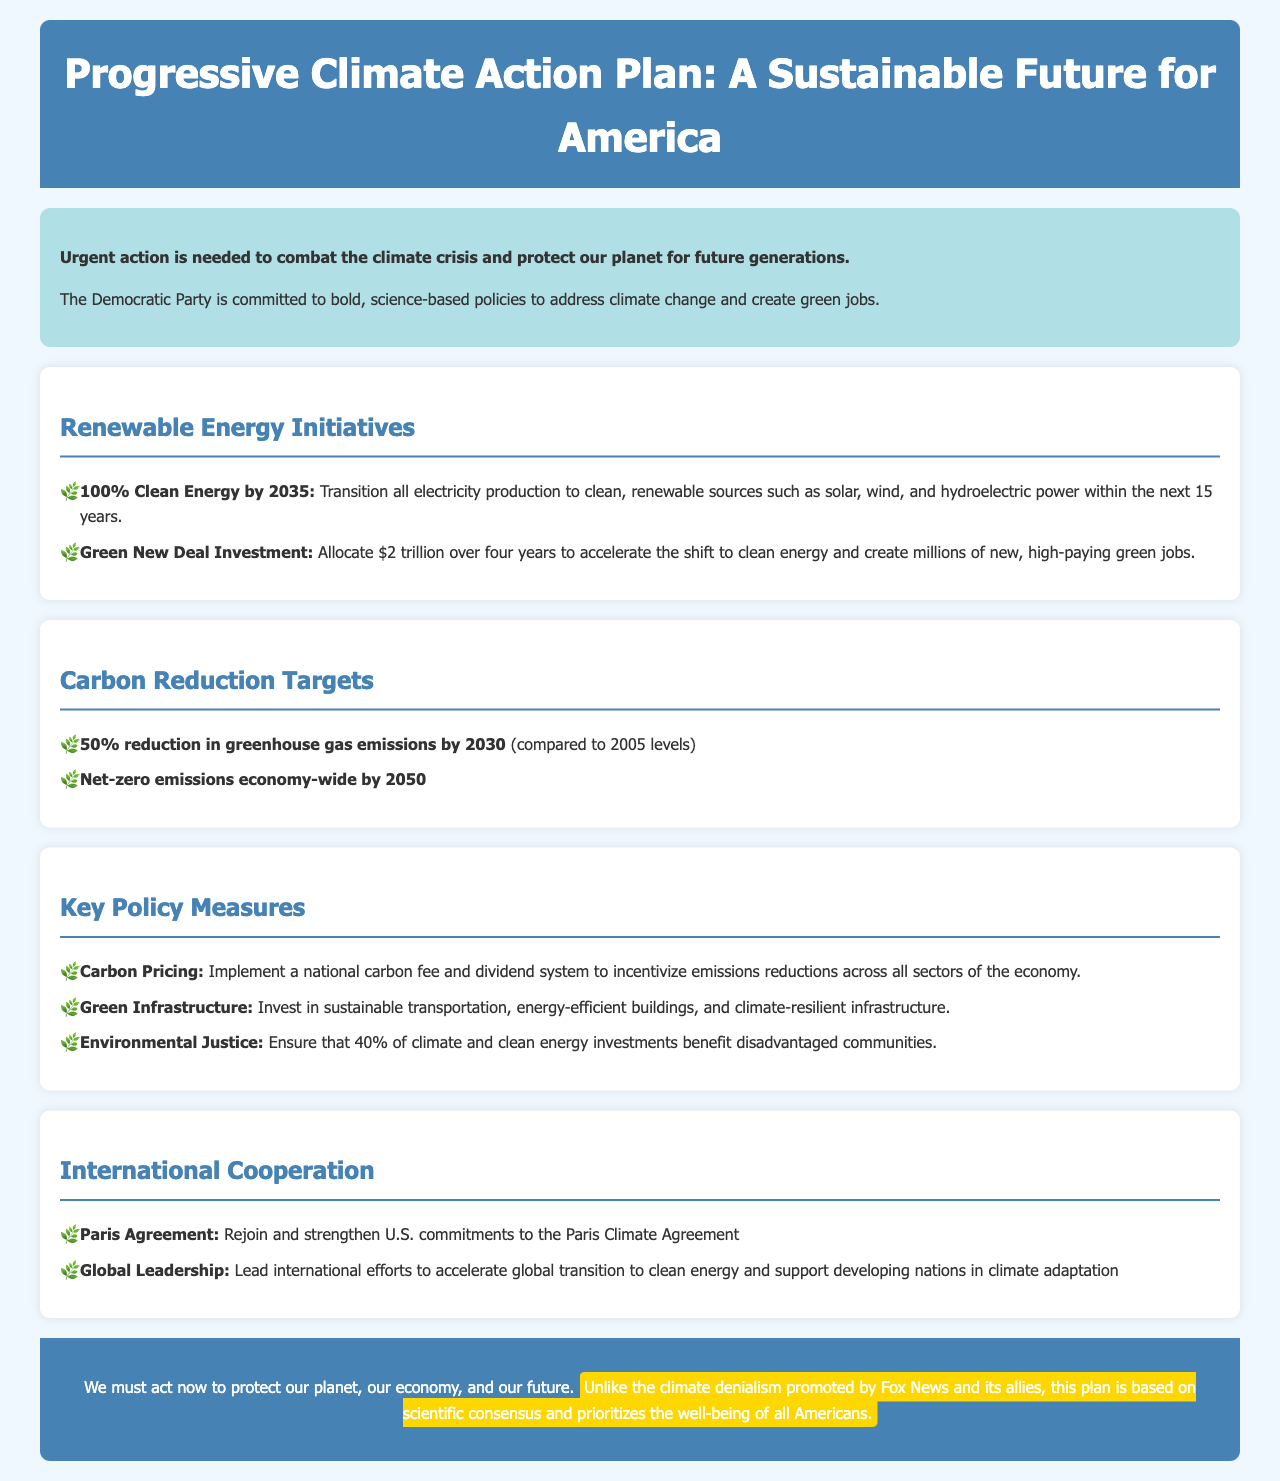what is the target year for 100% clean energy? The document states the target year for 100% clean energy is 2035.
Answer: 2035 how much funding is allocated for the Green New Deal? The document indicates that $2 trillion is allocated over four years for the Green New Deal.
Answer: $2 trillion what is the greenhouse gas emissions reduction target by 2030? The document specifies a 50% reduction in greenhouse gas emissions by 2030 compared to 2005 levels.
Answer: 50% what does the carbon pricing measure aim to achieve? The document outlines that carbon pricing aims to incentivize emissions reductions across all sectors of the economy.
Answer: Emissions reductions what percentage of climate investments should benefit disadvantaged communities? The document states that 40% of climate and clean energy investments should benefit disadvantaged communities.
Answer: 40% what international agreement does the document mention rejoining? The document mentions rejoining the Paris Climate Agreement.
Answer: Paris Agreement who does the document claim promotes climate denialism? The document explicitly states that Fox News and its allies promote climate denialism.
Answer: Fox News what is the overall goal of the Progressive Climate Action Plan? The document emphasizes the goal is to protect the planet, economy, and future through climate action.
Answer: Protect the planet, economy, and future 